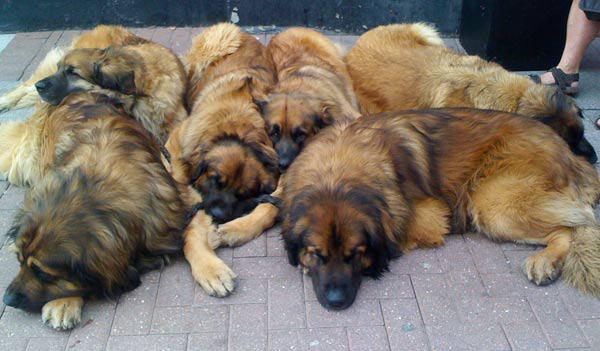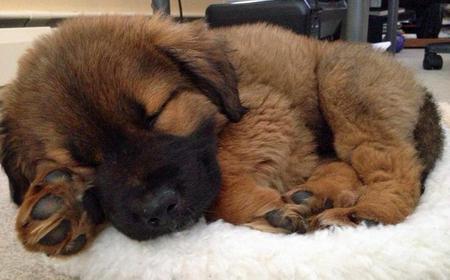The first image is the image on the left, the second image is the image on the right. For the images displayed, is the sentence "All the dogs are asleep." factually correct? Answer yes or no. Yes. The first image is the image on the left, the second image is the image on the right. Considering the images on both sides, is "The dog in the left image is awake and alert." valid? Answer yes or no. No. 